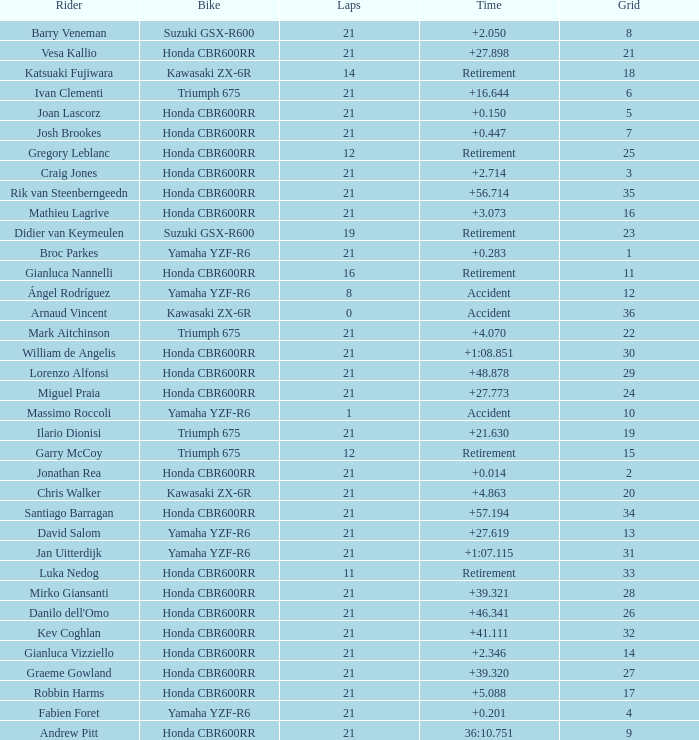Can you parse all the data within this table? {'header': ['Rider', 'Bike', 'Laps', 'Time', 'Grid'], 'rows': [['Barry Veneman', 'Suzuki GSX-R600', '21', '+2.050', '8'], ['Vesa Kallio', 'Honda CBR600RR', '21', '+27.898', '21'], ['Katsuaki Fujiwara', 'Kawasaki ZX-6R', '14', 'Retirement', '18'], ['Ivan Clementi', 'Triumph 675', '21', '+16.644', '6'], ['Joan Lascorz', 'Honda CBR600RR', '21', '+0.150', '5'], ['Josh Brookes', 'Honda CBR600RR', '21', '+0.447', '7'], ['Gregory Leblanc', 'Honda CBR600RR', '12', 'Retirement', '25'], ['Craig Jones', 'Honda CBR600RR', '21', '+2.714', '3'], ['Rik van Steenberngeedn', 'Honda CBR600RR', '21', '+56.714', '35'], ['Mathieu Lagrive', 'Honda CBR600RR', '21', '+3.073', '16'], ['Didier van Keymeulen', 'Suzuki GSX-R600', '19', 'Retirement', '23'], ['Broc Parkes', 'Yamaha YZF-R6', '21', '+0.283', '1'], ['Gianluca Nannelli', 'Honda CBR600RR', '16', 'Retirement', '11'], ['Ángel Rodríguez', 'Yamaha YZF-R6', '8', 'Accident', '12'], ['Arnaud Vincent', 'Kawasaki ZX-6R', '0', 'Accident', '36'], ['Mark Aitchinson', 'Triumph 675', '21', '+4.070', '22'], ['William de Angelis', 'Honda CBR600RR', '21', '+1:08.851', '30'], ['Lorenzo Alfonsi', 'Honda CBR600RR', '21', '+48.878', '29'], ['Miguel Praia', 'Honda CBR600RR', '21', '+27.773', '24'], ['Massimo Roccoli', 'Yamaha YZF-R6', '1', 'Accident', '10'], ['Ilario Dionisi', 'Triumph 675', '21', '+21.630', '19'], ['Garry McCoy', 'Triumph 675', '12', 'Retirement', '15'], ['Jonathan Rea', 'Honda CBR600RR', '21', '+0.014', '2'], ['Chris Walker', 'Kawasaki ZX-6R', '21', '+4.863', '20'], ['Santiago Barragan', 'Honda CBR600RR', '21', '+57.194', '34'], ['David Salom', 'Yamaha YZF-R6', '21', '+27.619', '13'], ['Jan Uitterdijk', 'Yamaha YZF-R6', '21', '+1:07.115', '31'], ['Luka Nedog', 'Honda CBR600RR', '11', 'Retirement', '33'], ['Mirko Giansanti', 'Honda CBR600RR', '21', '+39.321', '28'], ["Danilo dell'Omo", 'Honda CBR600RR', '21', '+46.341', '26'], ['Kev Coghlan', 'Honda CBR600RR', '21', '+41.111', '32'], ['Gianluca Vizziello', 'Honda CBR600RR', '21', '+2.346', '14'], ['Graeme Gowland', 'Honda CBR600RR', '21', '+39.320', '27'], ['Robbin Harms', 'Honda CBR600RR', '21', '+5.088', '17'], ['Fabien Foret', 'Yamaha YZF-R6', '21', '+0.201', '4'], ['Andrew Pitt', 'Honda CBR600RR', '21', '36:10.751', '9']]} What is the driver with the laps under 16, grid of 10, a bike of Yamaha YZF-R6, and ended with an accident? Massimo Roccoli. 